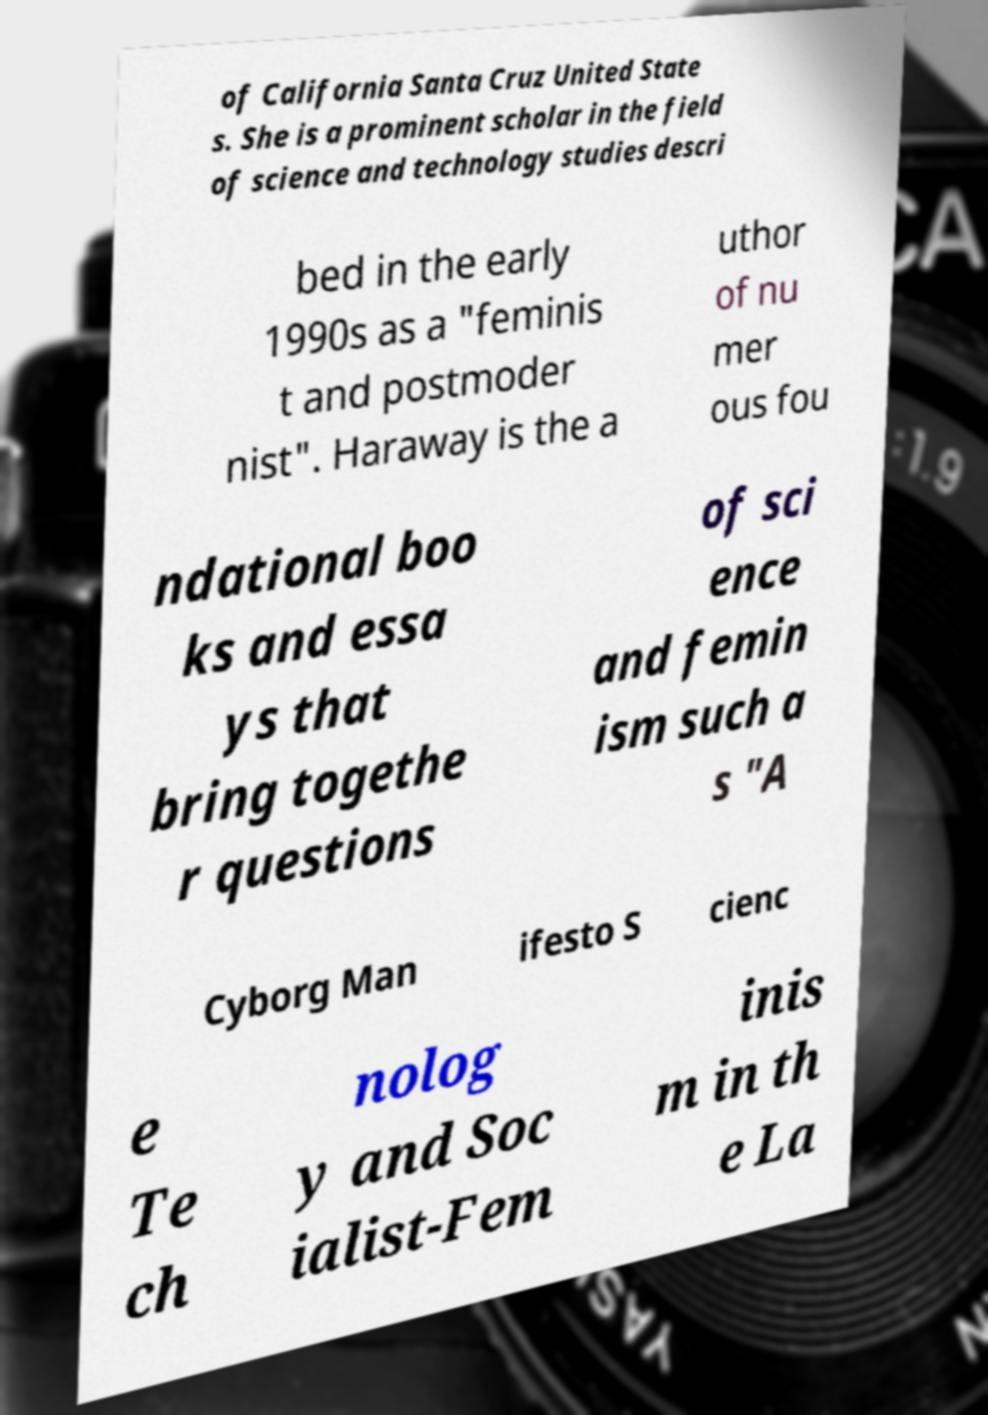I need the written content from this picture converted into text. Can you do that? of California Santa Cruz United State s. She is a prominent scholar in the field of science and technology studies descri bed in the early 1990s as a "feminis t and postmoder nist". Haraway is the a uthor of nu mer ous fou ndational boo ks and essa ys that bring togethe r questions of sci ence and femin ism such a s "A Cyborg Man ifesto S cienc e Te ch nolog y and Soc ialist-Fem inis m in th e La 